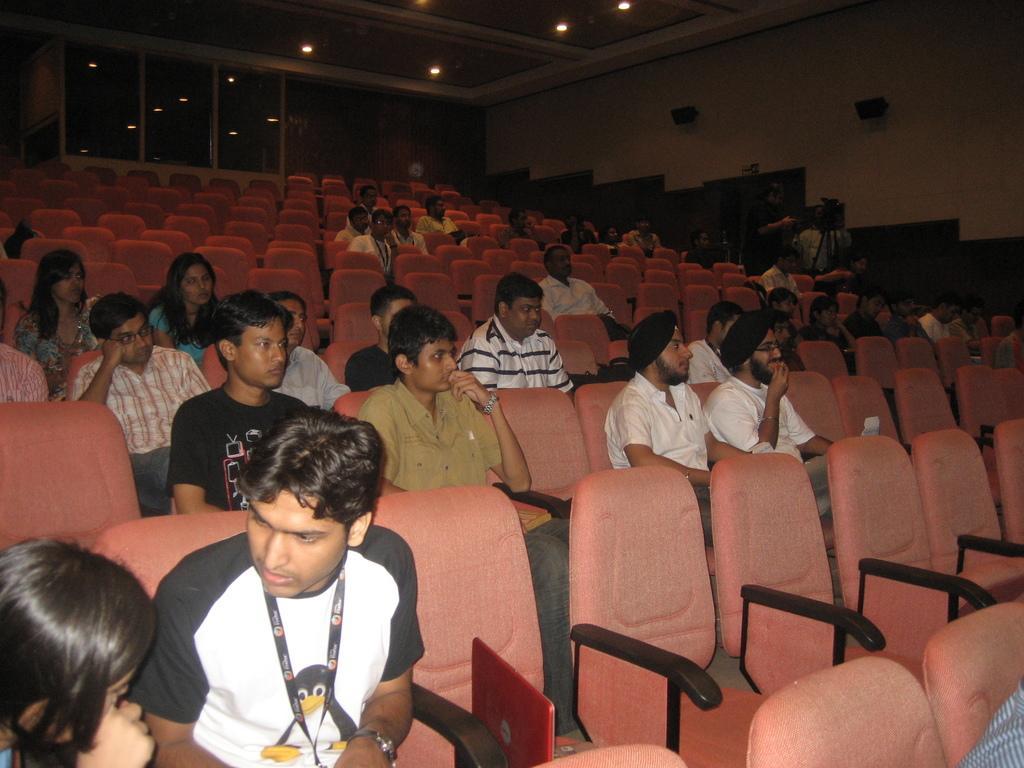Can you describe this image briefly? In this image I can see group of people sitting on the chairs and the chairs on the brown color. Background I can see the wall, few lights and glass windows. 